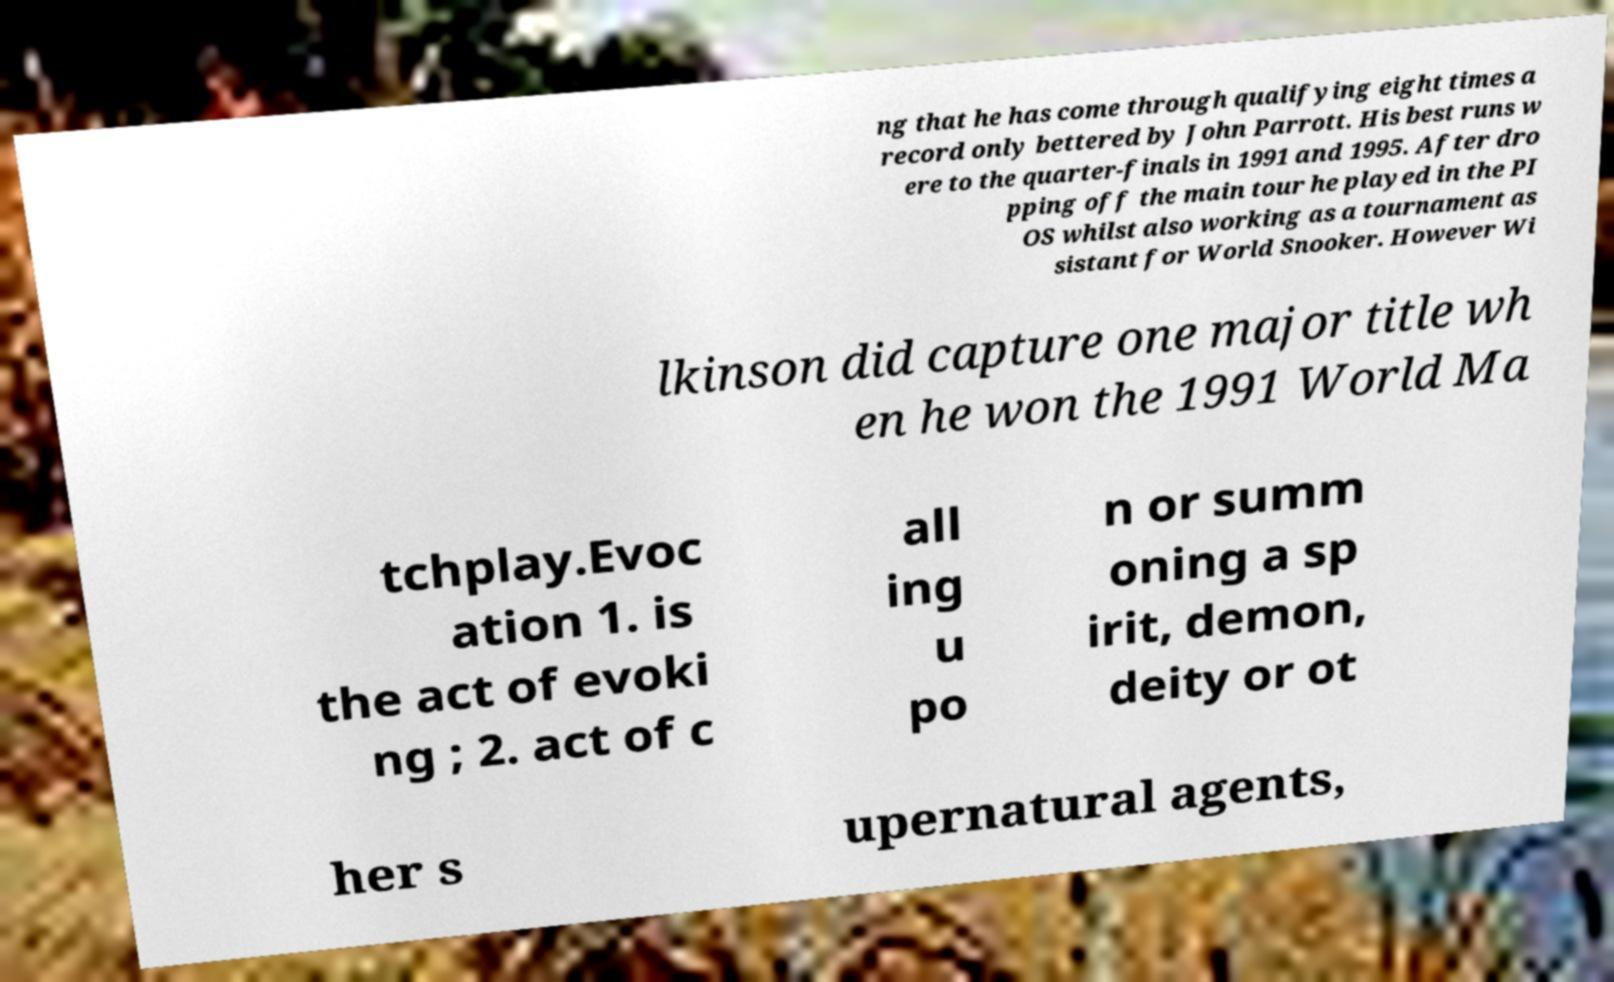For documentation purposes, I need the text within this image transcribed. Could you provide that? ng that he has come through qualifying eight times a record only bettered by John Parrott. His best runs w ere to the quarter-finals in 1991 and 1995. After dro pping off the main tour he played in the PI OS whilst also working as a tournament as sistant for World Snooker. However Wi lkinson did capture one major title wh en he won the 1991 World Ma tchplay.Evoc ation 1. is the act of evoki ng ; 2. act of c all ing u po n or summ oning a sp irit, demon, deity or ot her s upernatural agents, 